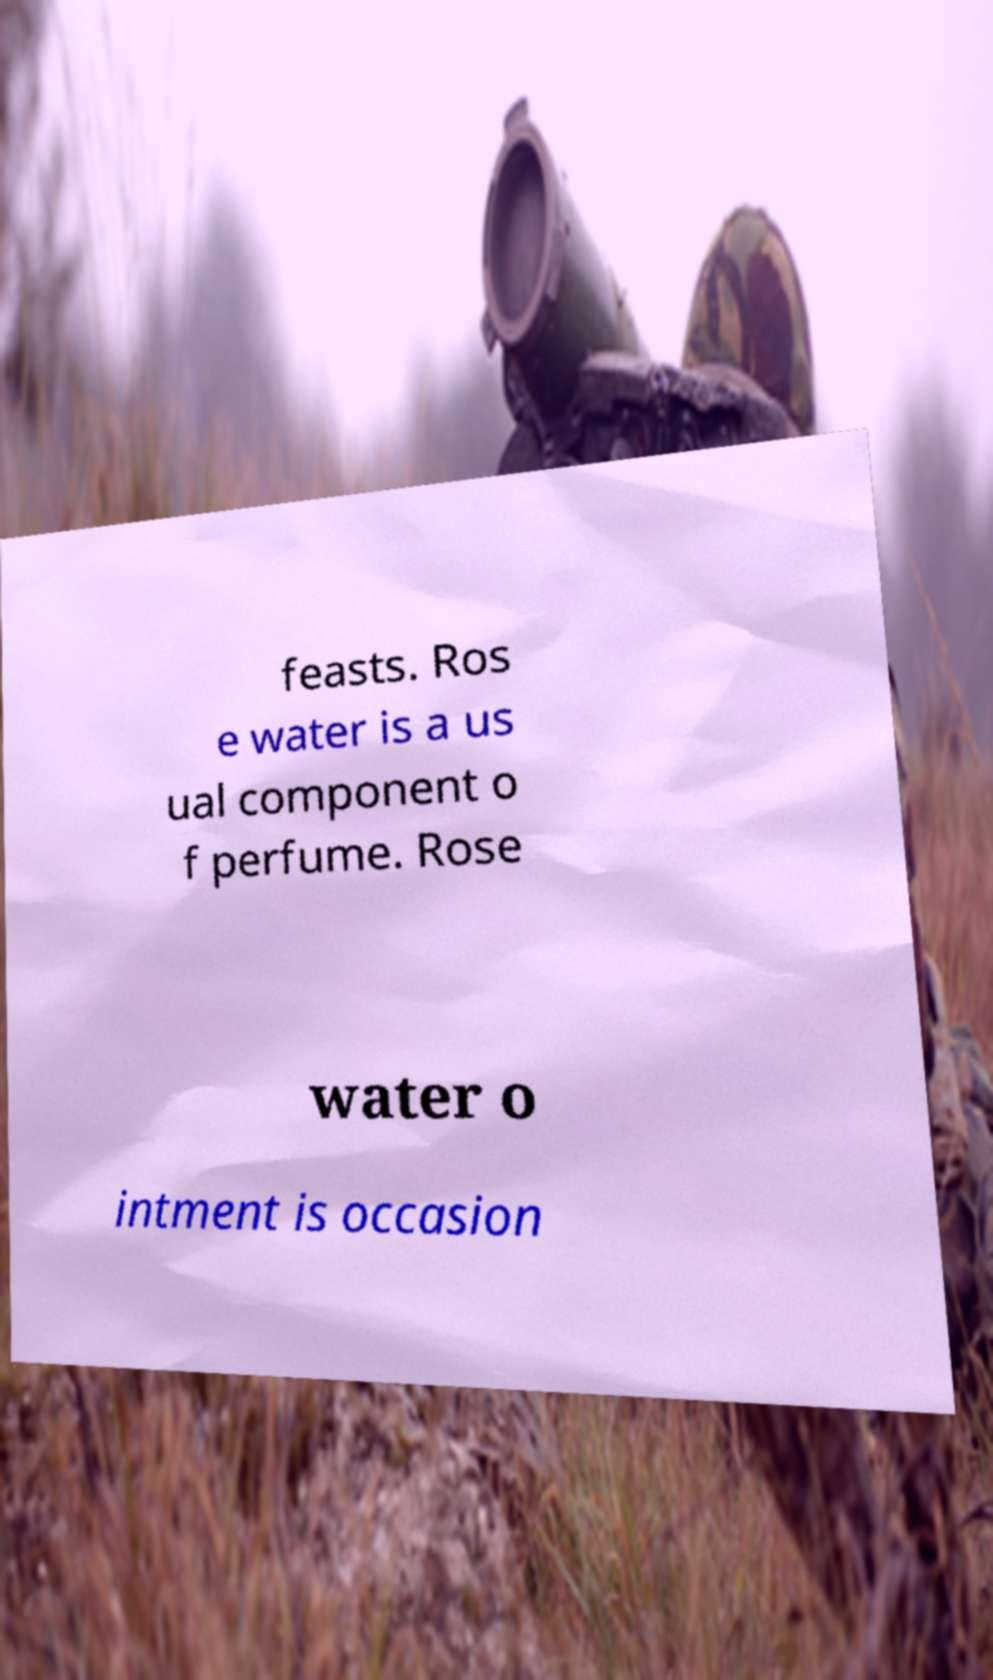For documentation purposes, I need the text within this image transcribed. Could you provide that? feasts. Ros e water is a us ual component o f perfume. Rose water o intment is occasion 